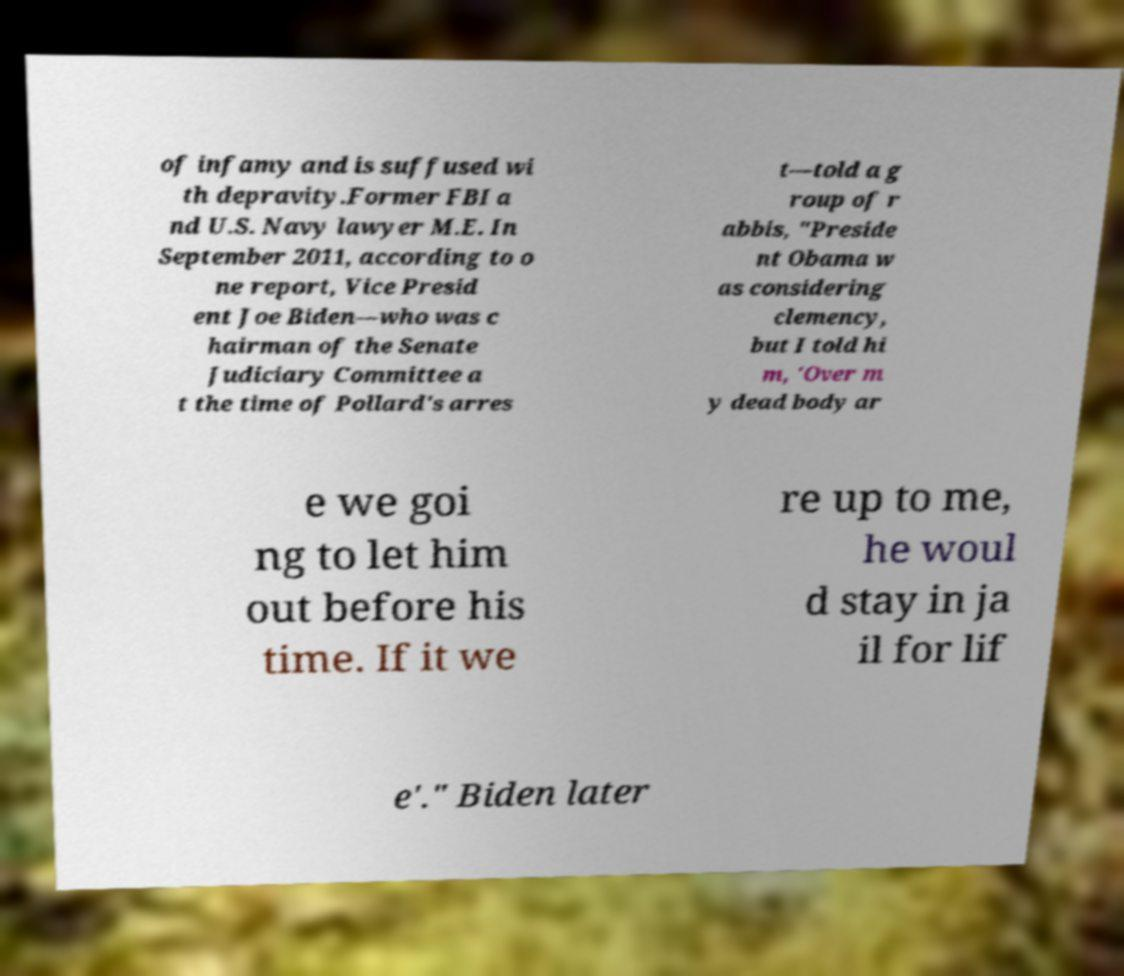Could you assist in decoding the text presented in this image and type it out clearly? of infamy and is suffused wi th depravity.Former FBI a nd U.S. Navy lawyer M.E. In September 2011, according to o ne report, Vice Presid ent Joe Biden—who was c hairman of the Senate Judiciary Committee a t the time of Pollard's arres t—told a g roup of r abbis, "Preside nt Obama w as considering clemency, but I told hi m, 'Over m y dead body ar e we goi ng to let him out before his time. If it we re up to me, he woul d stay in ja il for lif e'." Biden later 